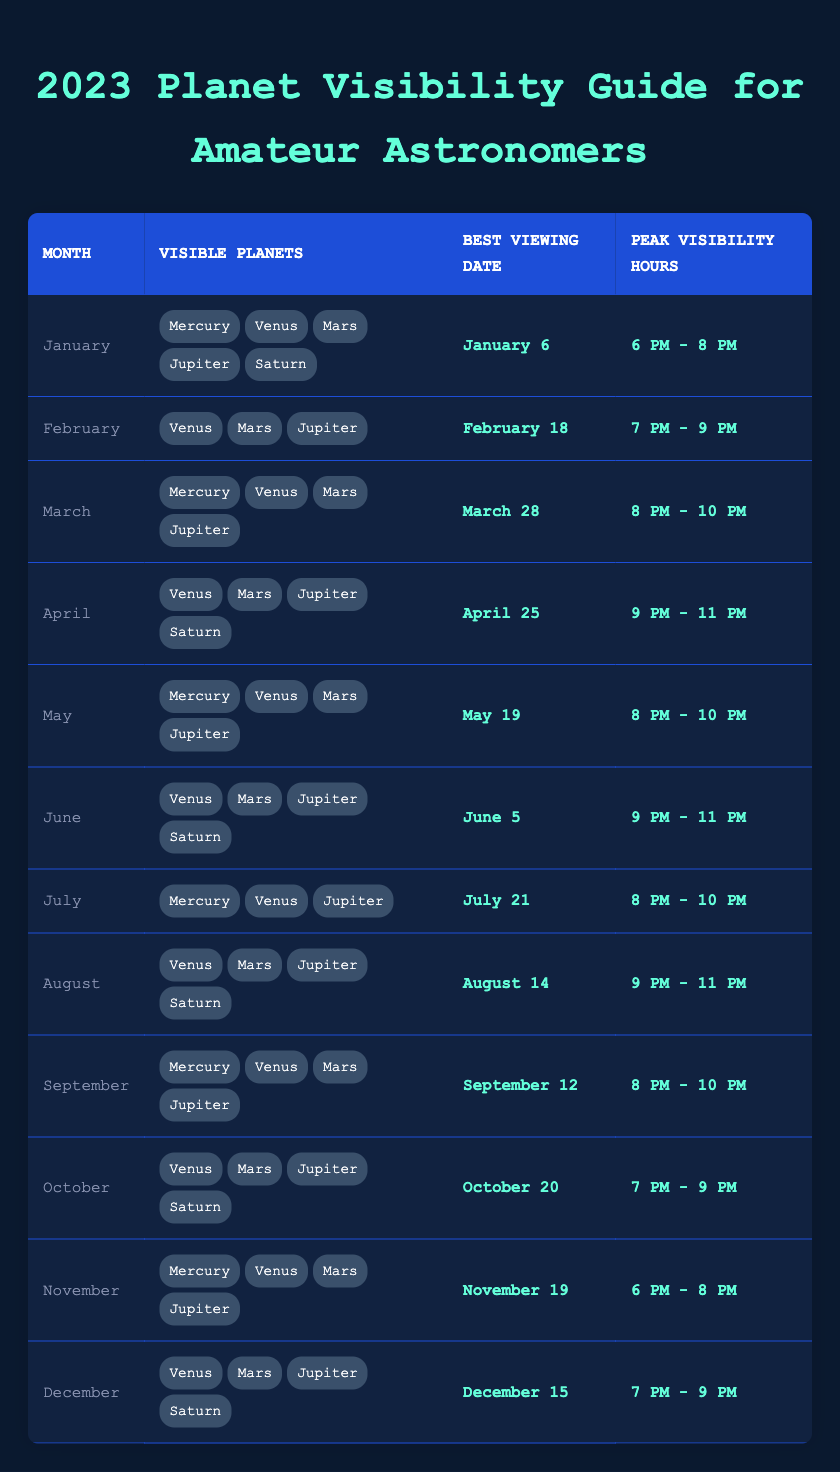What planets were visible in February 2023? In February 2023, the visible planets are listed in the table under the month of February. They are Venus, Mars, and Jupiter.
Answer: Venus, Mars, Jupiter What is the best viewing date for Saturn in the month of April? The table indicates that the best viewing date for Saturn in April 2023 is April 25.
Answer: April 25 How many planets were visible in March 2023? Referring to the table for March 2023, the visible planets listed are Mercury, Venus, Mars, and Jupiter. This totals four planets.
Answer: 4 What are the peak visibility hours for visible planets in June 2023? The table shows that the peak visibility hours for the visible planets in June 2023 are from 9 PM to 11 PM.
Answer: 9 PM - 11 PM Is Venus visible in December 2023? According to the December entry in the table, Venus is listed as one of the visible planets. Therefore, the answer is yes.
Answer: Yes Which month has the most visible planets, and how many are there? By inspecting the table, January shows 5 visible planets: Mercury, Venus, Mars, Jupiter, and Saturn, which is more than any other month. Thus, January has the most visible planets.
Answer: January, 5 In which month are both Mercury and Saturn visible? By reviewing the table, only in January and April are both Mercury and Saturn listed as visible planets. January has 5 visible planets, while April has 4. This requires looking for overlaps in the 'visible planets' list for both months.
Answer: January and April Which two months have peak visibility hours starting with "8 PM"? Looking at the peak visibility hours in the table, March and May both start their hours with "8 PM." Therefore, these two months match the criteria.
Answer: March, May How many total viewing dates are listed from January to March? The best viewing dates for January, February, and March are January 6, February 18, and March 28 respectively. Thus, there are 3 total viewing dates for these three months.
Answer: 3 